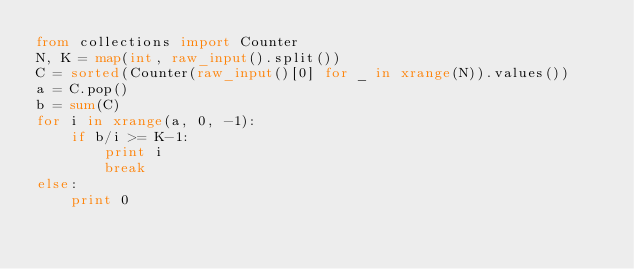<code> <loc_0><loc_0><loc_500><loc_500><_Python_>from collections import Counter
N, K = map(int, raw_input().split())
C = sorted(Counter(raw_input()[0] for _ in xrange(N)).values())
a = C.pop()
b = sum(C)
for i in xrange(a, 0, -1):
    if b/i >= K-1:
        print i
        break
else:
    print 0</code> 